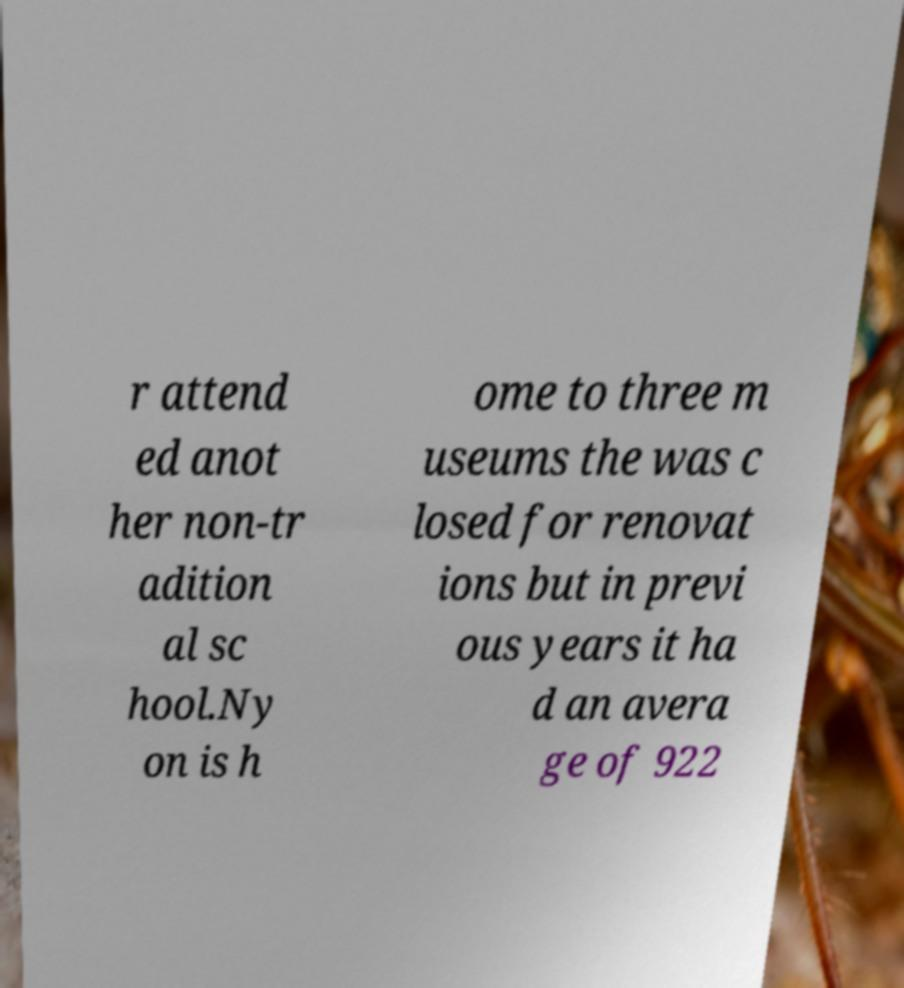Can you read and provide the text displayed in the image?This photo seems to have some interesting text. Can you extract and type it out for me? r attend ed anot her non-tr adition al sc hool.Ny on is h ome to three m useums the was c losed for renovat ions but in previ ous years it ha d an avera ge of 922 